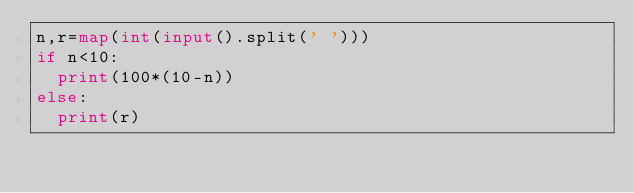Convert code to text. <code><loc_0><loc_0><loc_500><loc_500><_Python_>n,r=map(int(input().split(' ')))
if n<10:
  print(100*(10-n))
else:
  print(r)</code> 